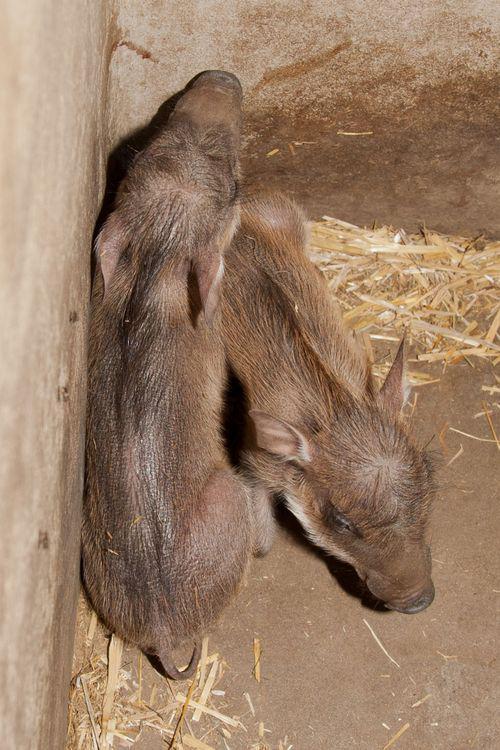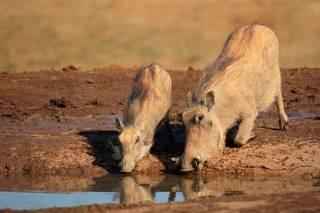The first image is the image on the left, the second image is the image on the right. For the images displayed, is the sentence "Some baby pigs are cuddling near a wall." factually correct? Answer yes or no. Yes. The first image is the image on the left, the second image is the image on the right. Assess this claim about the two images: "There are at least two piglets lying down.". Correct or not? Answer yes or no. Yes. 